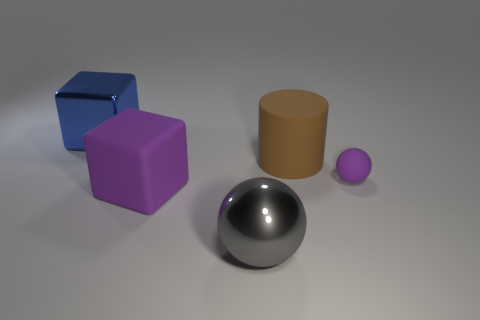Is there any other thing that has the same size as the purple matte ball?
Your answer should be very brief. No. What number of small things are either metallic balls or red shiny objects?
Provide a short and direct response. 0. Is the number of purple rubber things in front of the brown cylinder greater than the number of tiny rubber objects that are in front of the big purple matte thing?
Your answer should be compact. Yes. What size is the matte object that is the same color as the large matte cube?
Offer a very short reply. Small. What number of other things are the same size as the metallic cube?
Offer a terse response. 3. Do the cube that is in front of the blue metallic cube and the large gray sphere have the same material?
Offer a terse response. No. How many other things are the same color as the metal sphere?
Keep it short and to the point. 0. What number of other objects are the same shape as the large brown thing?
Your response must be concise. 0. Do the big metallic object in front of the blue shiny block and the rubber thing to the left of the large gray metal thing have the same shape?
Your response must be concise. No. Are there an equal number of purple things behind the tiny thing and large purple matte objects that are left of the big blue metallic cube?
Ensure brevity in your answer.  Yes. 